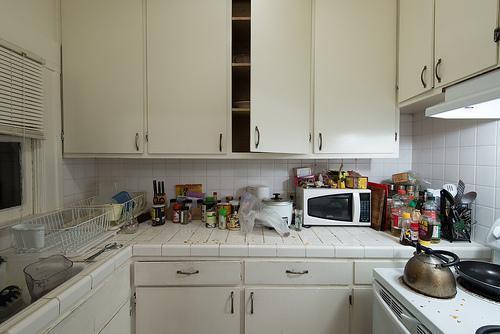How many cupboards are open?
Give a very brief answer. 1. 